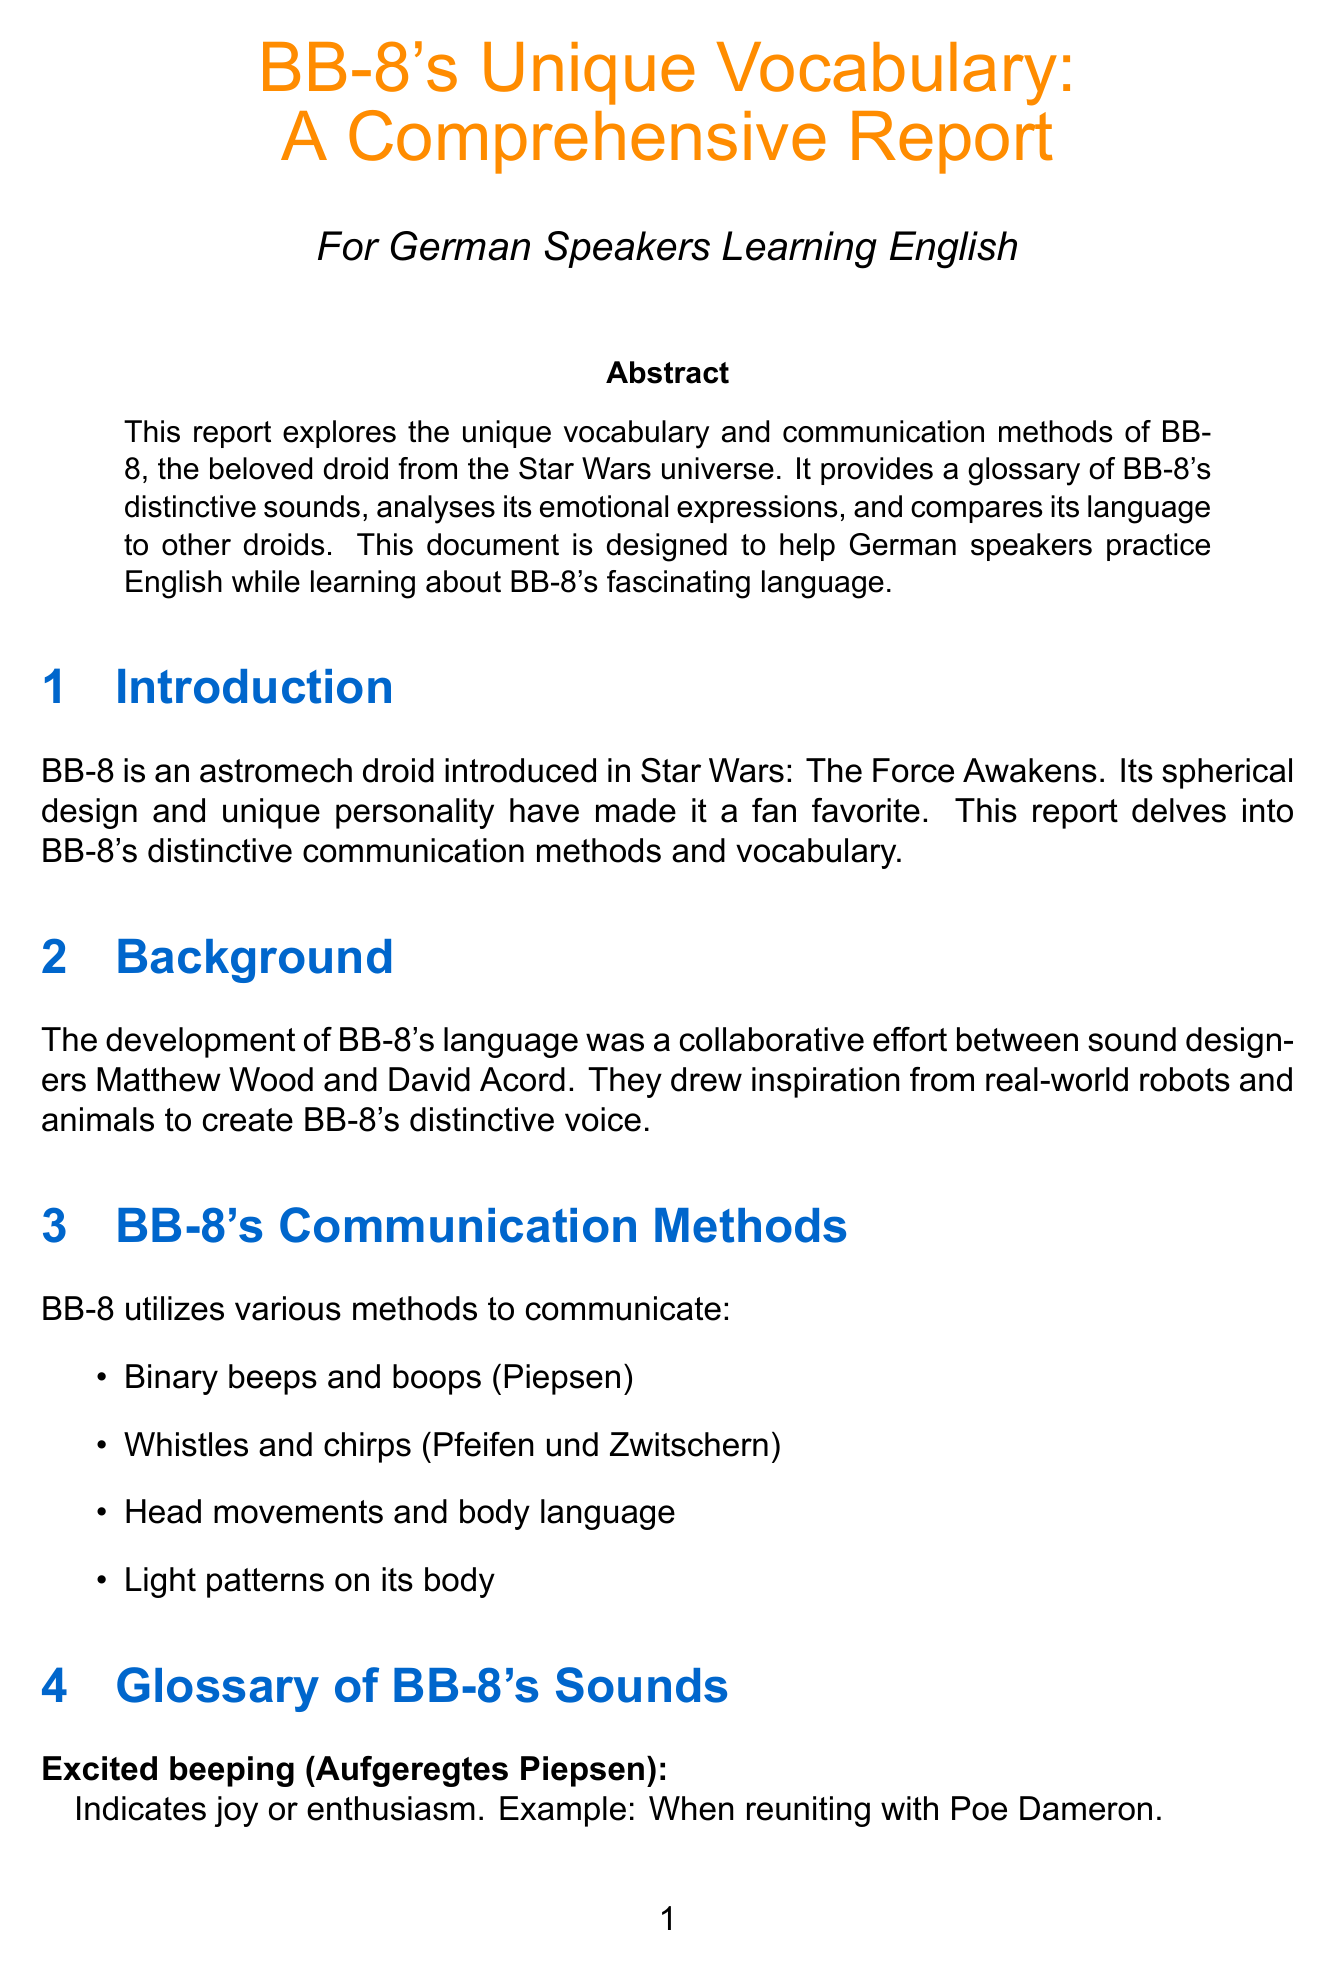What is the title of the report? The title of the report is found prominently at the beginning of the document.
Answer: BB-8's Unique Vocabulary: A Comprehensive Report Who are the sound designers behind BB-8's sounds? The report mentions the names of the sound designers responsible for creating BB-8's sounds.
Answer: Matthew Wood and David Acord What sound indicates joy or enthusiasm? The glossary section provides meanings for different sounds made by BB-8.
Answer: Excited beeping Which droid uses human language? The comparison section outlines the differences between BB-8 and another droid, indicating how one communicates.
Answer: C-3PO How does BB-8 express urgency? The emotional expression section describes how BB-8 can convey urgency through certain techniques.
Answer: Speed and rhythm of beeps What is one of BB-8's communication methods? The document lists various methods BB-8 uses to communicate.
Answer: Binary beeps and boops What type of tones indicate curiosity? The glossary provides examples of sounds and their meanings, including those that show curiosity.
Answer: Soft, melodic tones What book can be referenced for learning more about BB-8's language? The resources section recommends literature for further exploration of the topic.
Answer: Star Wars: The Force Awakens Visual Dictionary 